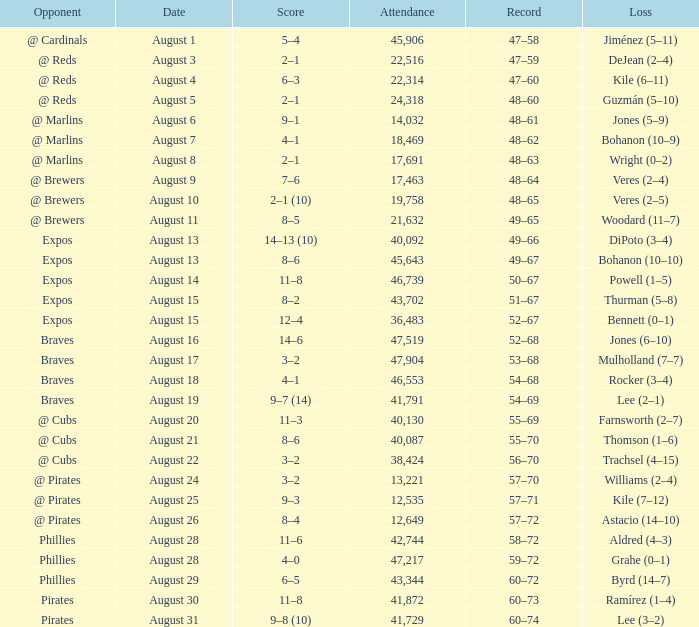I'm looking to parse the entire table for insights. Could you assist me with that? {'header': ['Opponent', 'Date', 'Score', 'Attendance', 'Record', 'Loss'], 'rows': [['@ Cardinals', 'August 1', '5–4', '45,906', '47–58', 'Jiménez (5–11)'], ['@ Reds', 'August 3', '2–1', '22,516', '47–59', 'DeJean (2–4)'], ['@ Reds', 'August 4', '6–3', '22,314', '47–60', 'Kile (6–11)'], ['@ Reds', 'August 5', '2–1', '24,318', '48–60', 'Guzmán (5–10)'], ['@ Marlins', 'August 6', '9–1', '14,032', '48–61', 'Jones (5–9)'], ['@ Marlins', 'August 7', '4–1', '18,469', '48–62', 'Bohanon (10–9)'], ['@ Marlins', 'August 8', '2–1', '17,691', '48–63', 'Wright (0–2)'], ['@ Brewers', 'August 9', '7–6', '17,463', '48–64', 'Veres (2–4)'], ['@ Brewers', 'August 10', '2–1 (10)', '19,758', '48–65', 'Veres (2–5)'], ['@ Brewers', 'August 11', '8–5', '21,632', '49–65', 'Woodard (11–7)'], ['Expos', 'August 13', '14–13 (10)', '40,092', '49–66', 'DiPoto (3–4)'], ['Expos', 'August 13', '8–6', '45,643', '49–67', 'Bohanon (10–10)'], ['Expos', 'August 14', '11–8', '46,739', '50–67', 'Powell (1–5)'], ['Expos', 'August 15', '8–2', '43,702', '51–67', 'Thurman (5–8)'], ['Expos', 'August 15', '12–4', '36,483', '52–67', 'Bennett (0–1)'], ['Braves', 'August 16', '14–6', '47,519', '52–68', 'Jones (6–10)'], ['Braves', 'August 17', '3–2', '47,904', '53–68', 'Mulholland (7–7)'], ['Braves', 'August 18', '4–1', '46,553', '54–68', 'Rocker (3–4)'], ['Braves', 'August 19', '9–7 (14)', '41,791', '54–69', 'Lee (2–1)'], ['@ Cubs', 'August 20', '11–3', '40,130', '55–69', 'Farnsworth (2–7)'], ['@ Cubs', 'August 21', '8–6', '40,087', '55–70', 'Thomson (1–6)'], ['@ Cubs', 'August 22', '3–2', '38,424', '56–70', 'Trachsel (4–15)'], ['@ Pirates', 'August 24', '3–2', '13,221', '57–70', 'Williams (2–4)'], ['@ Pirates', 'August 25', '9–3', '12,535', '57–71', 'Kile (7–12)'], ['@ Pirates', 'August 26', '8–4', '12,649', '57–72', 'Astacio (14–10)'], ['Phillies', 'August 28', '11–6', '42,744', '58–72', 'Aldred (4–3)'], ['Phillies', 'August 28', '4–0', '47,217', '59–72', 'Grahe (0–1)'], ['Phillies', 'August 29', '6–5', '43,344', '60–72', 'Byrd (14–7)'], ['Pirates', 'August 30', '11–8', '41,872', '60–73', 'Ramírez (1–4)'], ['Pirates', 'August 31', '9–8 (10)', '41,729', '60–74', 'Lee (3–2)']]} What is the lowest attendance total on August 26? 12649.0. 